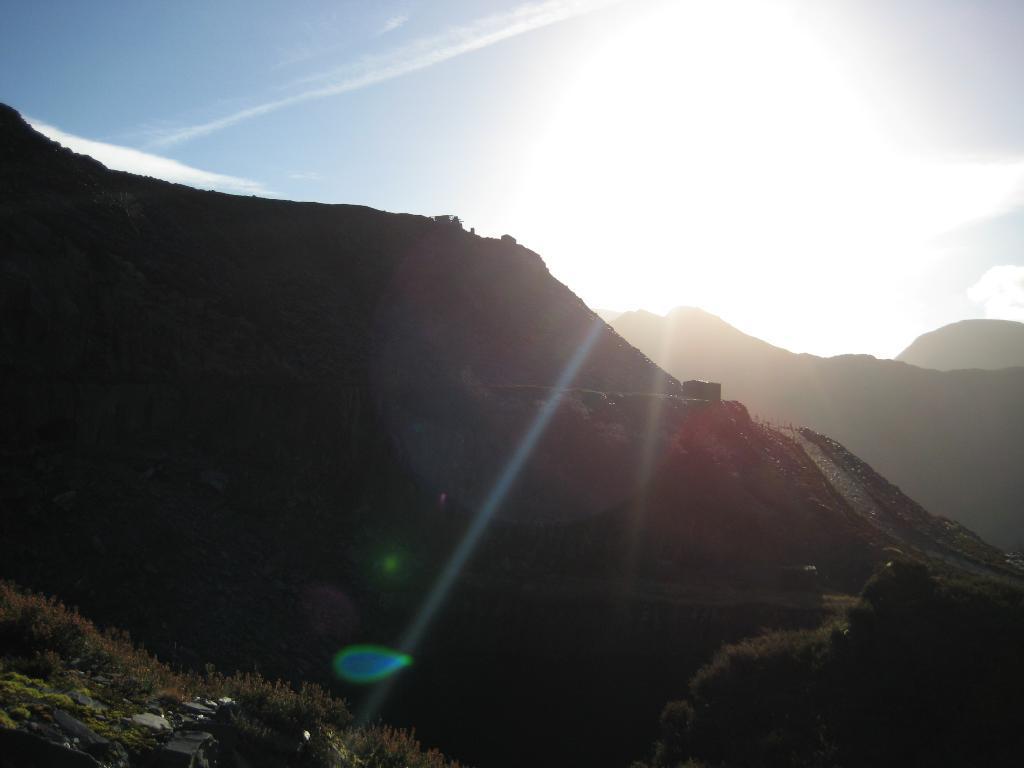Please provide a concise description of this image. In this image I can see few mountains and few trees on the mountains. In the background I can see the sky and the sun. 